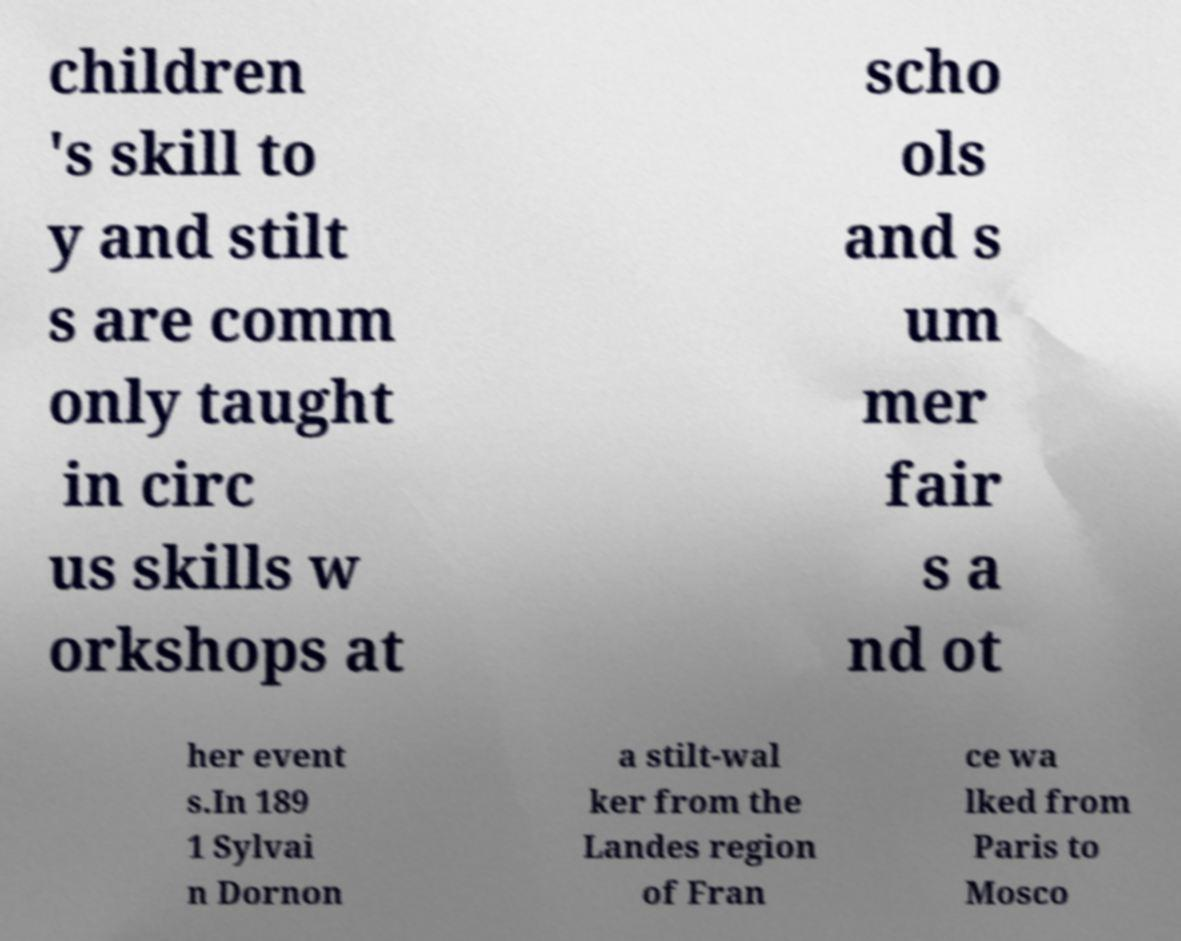For documentation purposes, I need the text within this image transcribed. Could you provide that? children 's skill to y and stilt s are comm only taught in circ us skills w orkshops at scho ols and s um mer fair s a nd ot her event s.In 189 1 Sylvai n Dornon a stilt-wal ker from the Landes region of Fran ce wa lked from Paris to Mosco 